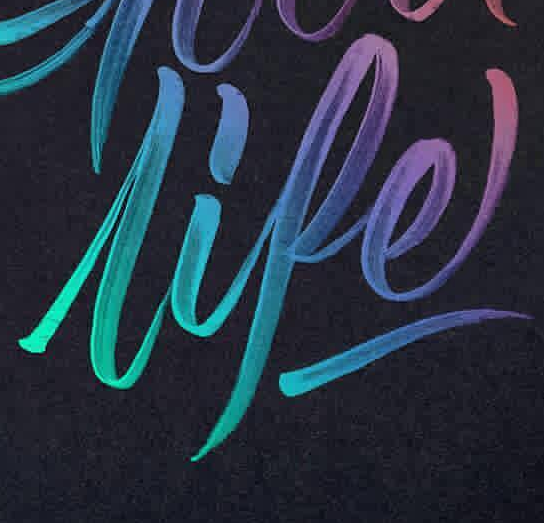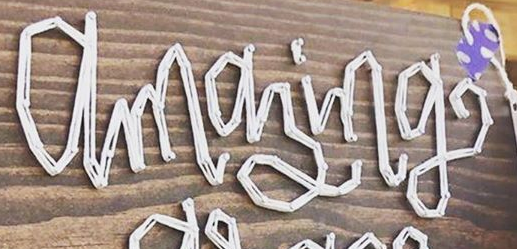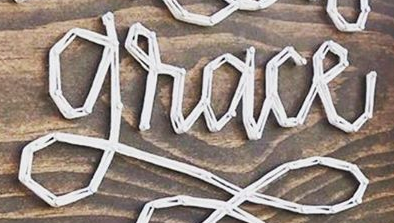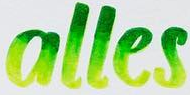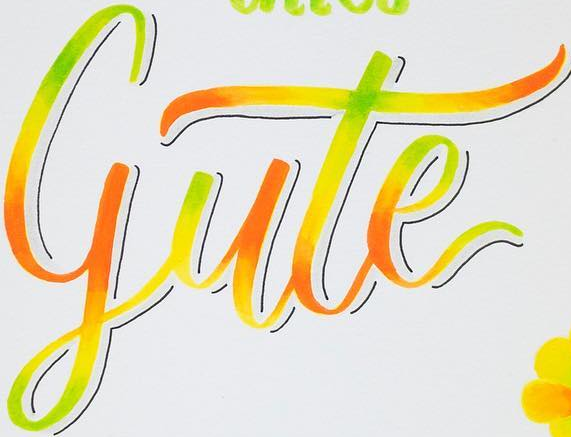What words can you see in these images in sequence, separated by a semicolon? lipe; amazing; grace; alles; gute 